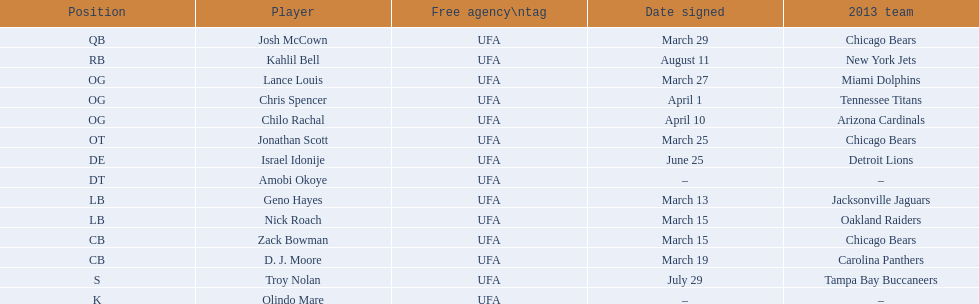Who are all the individuals involved? Josh McCown, Kahlil Bell, Lance Louis, Chris Spencer, Chilo Rachal, Jonathan Scott, Israel Idonije, Amobi Okoye, Geno Hayes, Nick Roach, Zack Bowman, D. J. Moore, Troy Nolan, Olindo Mare. When were they brought onboard? March 29, August 11, March 27, April 1, April 10, March 25, June 25, –, March 13, March 15, March 15, March 19, July 29, –. Apart from nick roach, who else joined on march 15? Zack Bowman. 